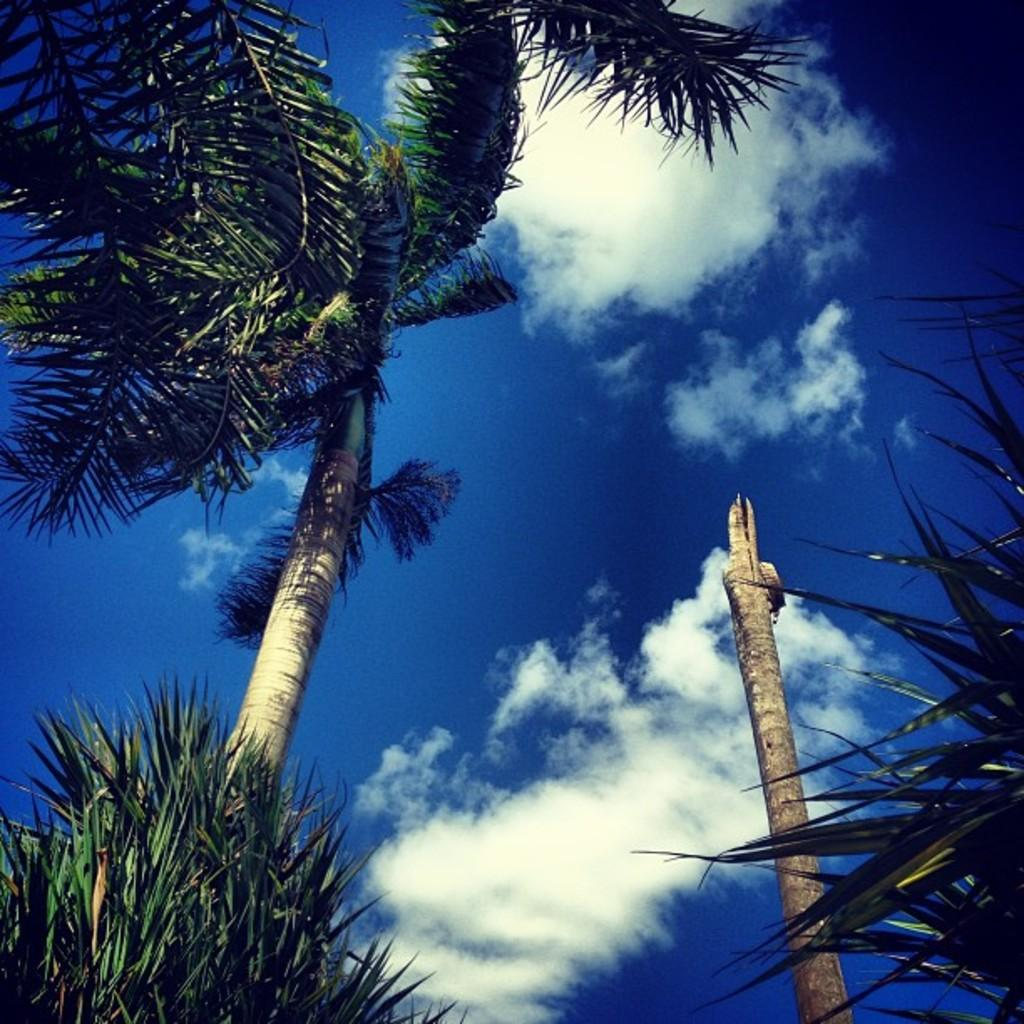What can be seen in the foreground of the image? There is greenery, a tree, and a wooden pole-like object in the foreground of the image. What is visible in the background of the image? The sky is visible at the top of the image. What can be observed in the sky? There are clouds in the sky. Are there any snakes visible in the image? There are no snakes present in the image. Can you see a cobweb on the tree in the image? There is no cobweb visible on the tree in the image. 